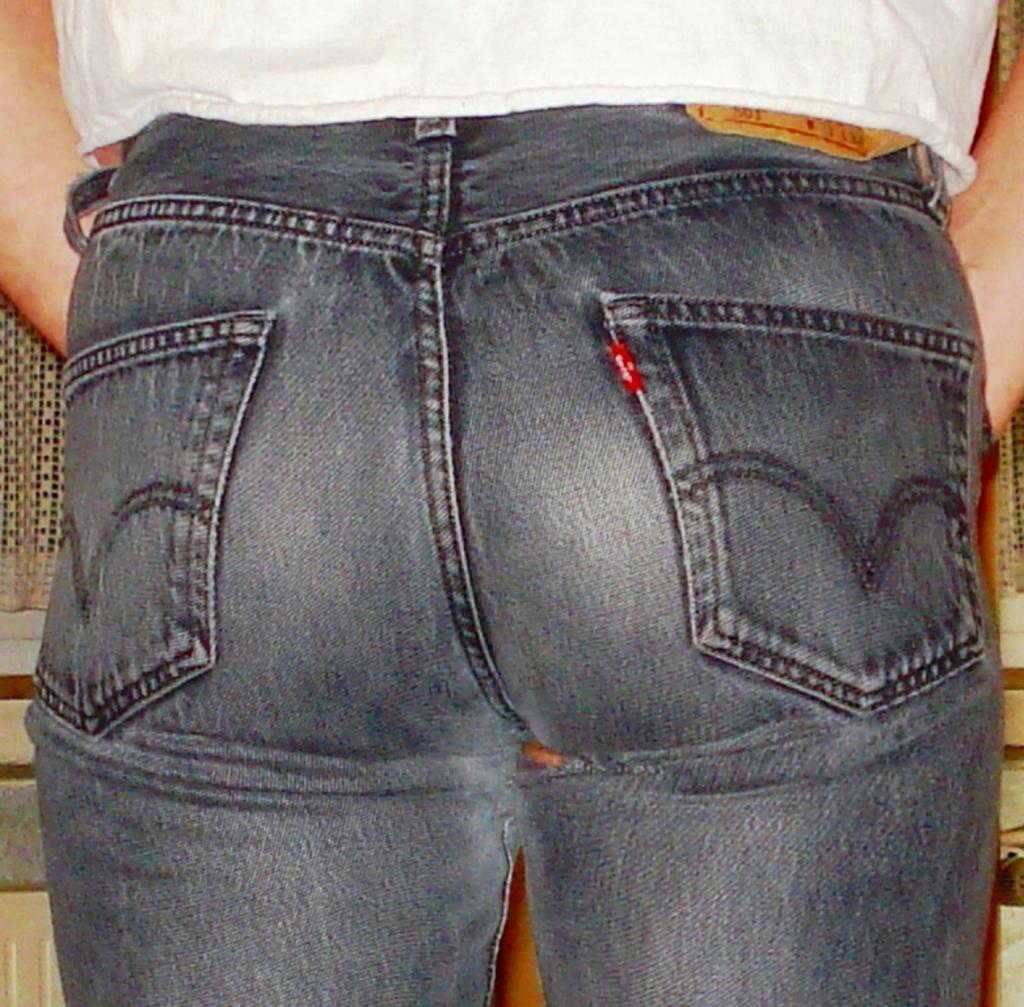What can be seen in the image? There is a person in the image. What type of clothing is the person wearing? The person is wearing jeans and a white top. Can you describe the object in front of the person? Unfortunately, the facts provided do not give any information about the object in front of the person. What type of insurance does the person in the image have? There is no information about the person's insurance in the image or the provided facts. 